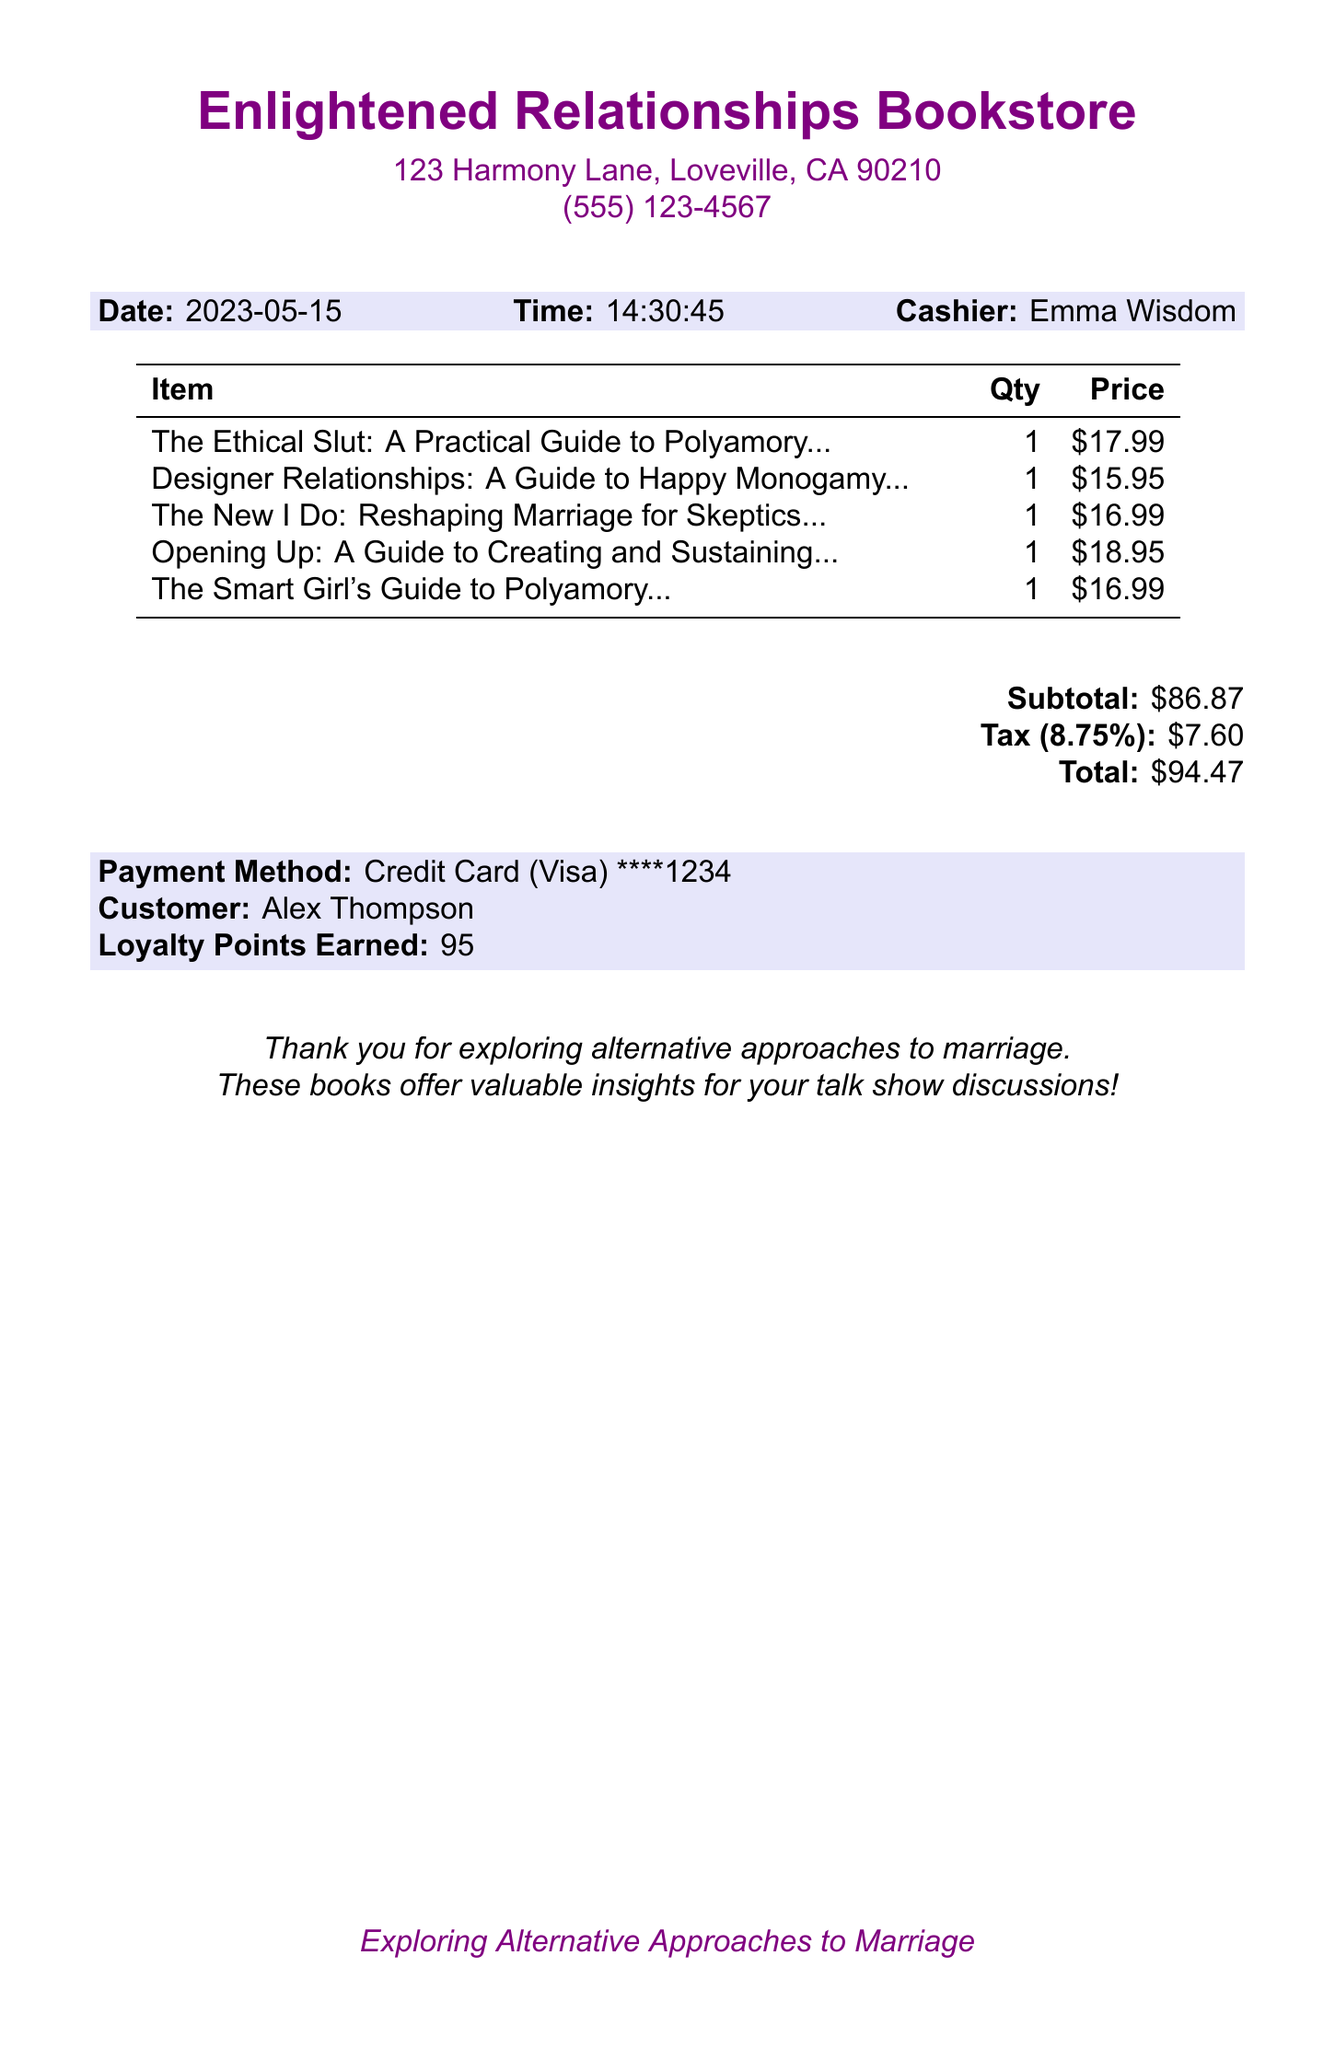What is the store name? The store name is located at the top of the receipt document.
Answer: Enlightened Relationships Bookstore What is the address of the bookstore? The address is mentioned under the store name in the document.
Answer: 123 Harmony Lane, Loveville, CA 90210 Who is the cashier? The cashier's name is provided in the receipt details.
Answer: Emma Wisdom What is the total amount spent? The total amount is listed in the financial section at the bottom of the document.
Answer: 94.47 How many loyalty points were earned? The loyalty points earned is specified towards the end of the receipt.
Answer: 95 What is the price of "Opening Up"? The price for this item is listed in the item table of the receipt.
Answer: 18.95 Which book focuses on reshaping marriage? This information can be found in the item titles on the receipt.
Answer: The New I Do: Reshaping Marriage for Skeptics, Realists and Rebels What payment method was used? The payment method is indicated in the payment section of the receipt.
Answer: Credit Card What was the tax rate? The tax rate is given in the details of the financial section of the document.
Answer: 8.75% 